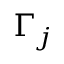Convert formula to latex. <formula><loc_0><loc_0><loc_500><loc_500>\Gamma _ { j }</formula> 